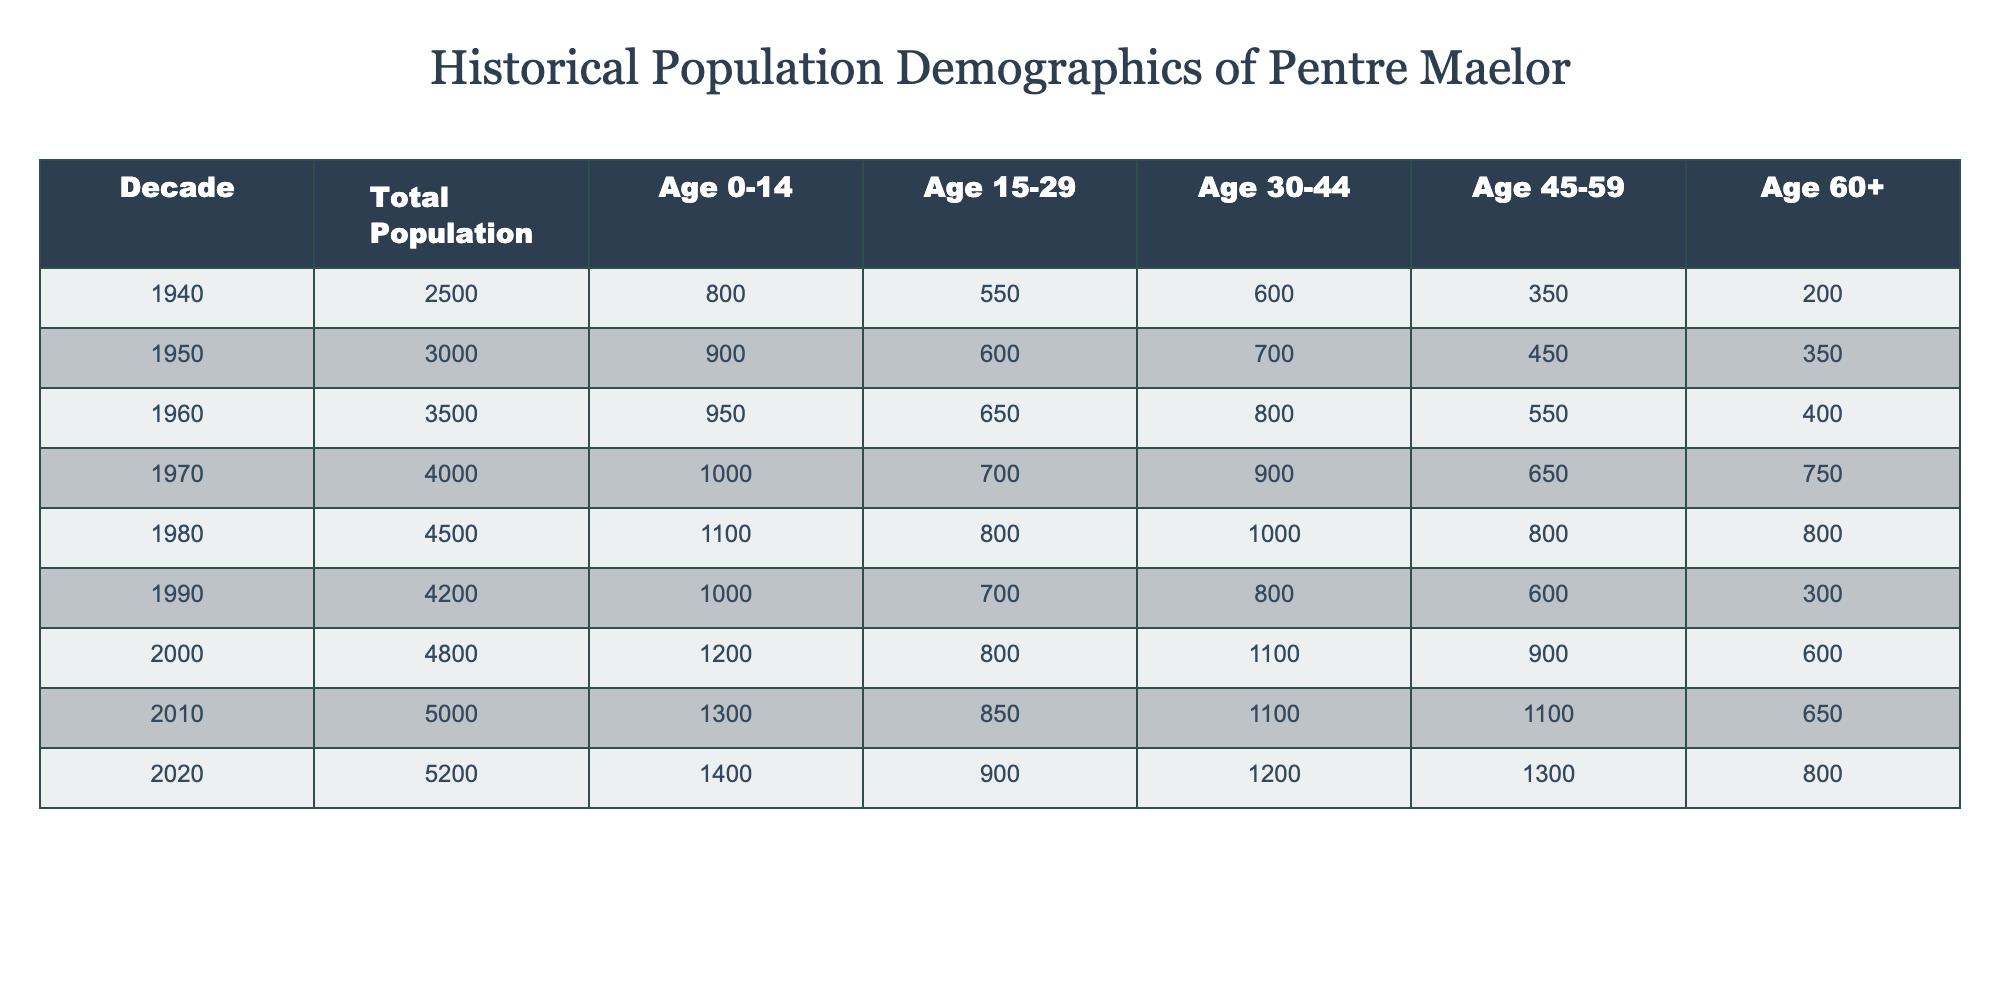What was the total population of Pentre Maelor in 1960? According to the table, the value under "Total Population" for the year 1960 is 3500.
Answer: 3500 In which decade did the population of individuals aged 15-29 peak? By examining the "Age 15-29" column, the highest value is 850, which occurs in the year 2010.
Answer: 2010 What is the total number of people aged 60 and over in the decade 1980 compared to 1940? In 1980, the total for "Age 60+" is 800, and in 1940 it is 200. To find the difference, calculate 800 - 200 = 600.
Answer: 600 Was the population of people aged 0-14 in 2020 higher than in 2000? By checking the "Age 0-14" values, in 2020 it is 1400, and in 2000 it is 1200. Since 1400 is greater than 1200, the statement is true.
Answer: Yes What was the average population of people aged 30-44 from 1940 to 2020? To find the average, sum the values for "Age 30-44" across the decades: (600 + 700 + 800 + 900 + 1000 + 800 + 1100 + 1100 + 1200) = 8200. Then, divide by the number of decades (9): 8200 / 9 ≈ 911.11.
Answer: Approximately 911.11 What was the trend in total population from 1940 to 2020? The table shows that the total population increased from 2500 in 1940 to 5200 in 2020. This indicates a consistent upward trend in the total population over the decades.
Answer: Increasing How many individuals aged 45-59 were there in 1970? The table indicates that the number of people aged 45-59 in 1970 is 650.
Answer: 650 What was the change in the total population from 1980 to 1990? The total population in 1980 is 4500, and in 1990 it is 4200. The change is calculated as 4200 - 4500 = -300, indicating a decrease.
Answer: Decrease of 300 How many more children aged 0-14 were there in 2020 compared to 1950? In 2020, the number of individuals aged 0-14 is 1400, and in 1950 it is 900. The difference is 1400 - 900 = 500.
Answer: 500 